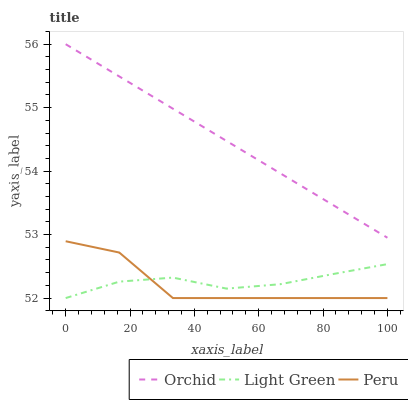Does Peru have the minimum area under the curve?
Answer yes or no. Yes. Does Orchid have the maximum area under the curve?
Answer yes or no. Yes. Does Light Green have the minimum area under the curve?
Answer yes or no. No. Does Light Green have the maximum area under the curve?
Answer yes or no. No. Is Orchid the smoothest?
Answer yes or no. Yes. Is Peru the roughest?
Answer yes or no. Yes. Is Light Green the smoothest?
Answer yes or no. No. Is Light Green the roughest?
Answer yes or no. No. Does Peru have the lowest value?
Answer yes or no. Yes. Does Orchid have the lowest value?
Answer yes or no. No. Does Orchid have the highest value?
Answer yes or no. Yes. Does Light Green have the highest value?
Answer yes or no. No. Is Peru less than Orchid?
Answer yes or no. Yes. Is Orchid greater than Peru?
Answer yes or no. Yes. Does Light Green intersect Peru?
Answer yes or no. Yes. Is Light Green less than Peru?
Answer yes or no. No. Is Light Green greater than Peru?
Answer yes or no. No. Does Peru intersect Orchid?
Answer yes or no. No. 